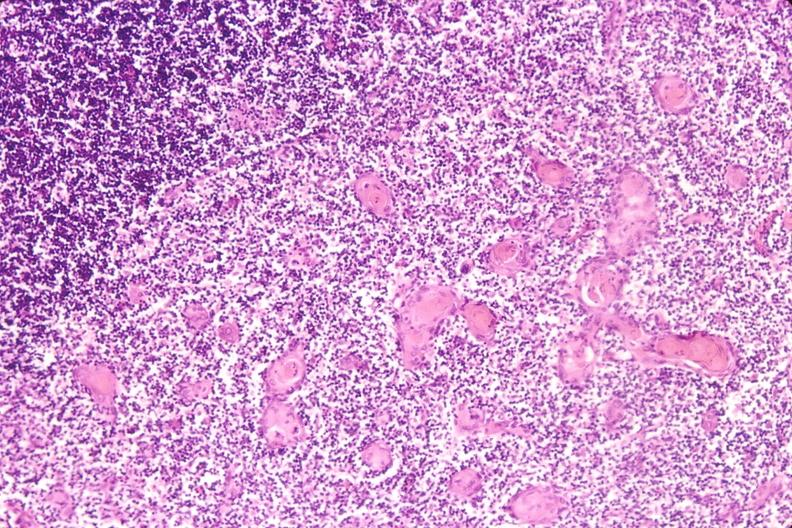s bicornate uterus present?
Answer the question using a single word or phrase. No 